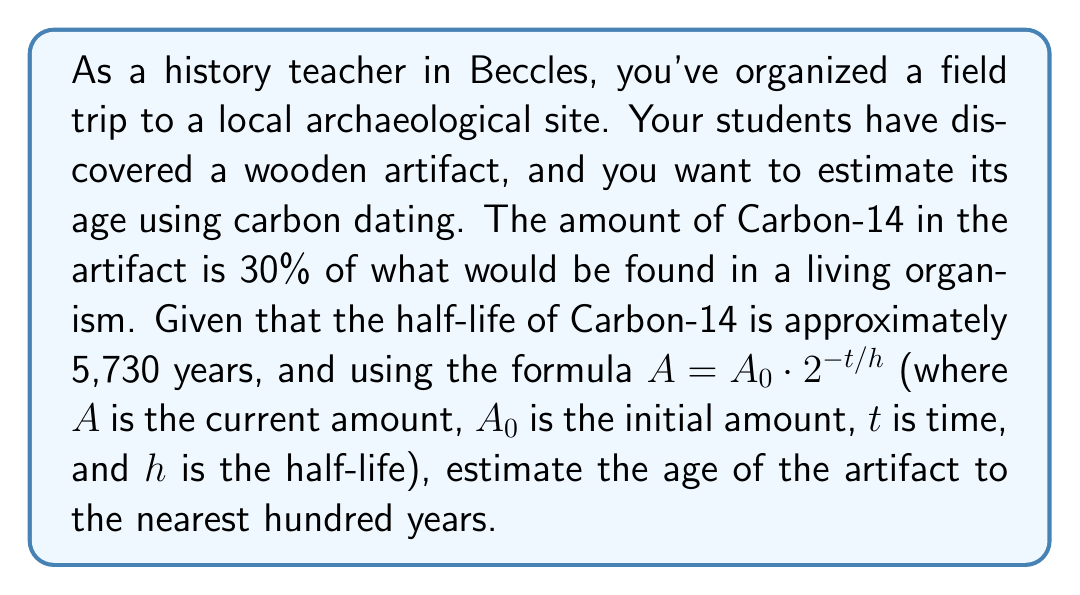Can you answer this question? Let's approach this step-by-step:

1) We're given the formula $A = A_0 \cdot 2^{-t/h}$

2) We know:
   - $A/A_0 = 0.30$ (current amount is 30% of initial)
   - $h = 5730$ years (half-life of Carbon-14)

3) Let's substitute these into the formula:

   $0.30 = 2^{-t/5730}$

4) To solve for $t$, we need to use logarithms. Let's take the natural log of both sides:

   $\ln(0.30) = \ln(2^{-t/5730})$

5) Using the logarithm property $\ln(x^n) = n\ln(x)$:

   $\ln(0.30) = -\frac{t}{5730}\ln(2)$

6) Now we can solve for $t$:

   $t = -5730 \cdot \frac{\ln(0.30)}{\ln(2)}$

7) Let's calculate this:

   $t \approx 9967.7$ years

8) Rounding to the nearest hundred years:

   $t \approx 10,000$ years
Answer: The estimated age of the artifact is approximately 10,000 years. 